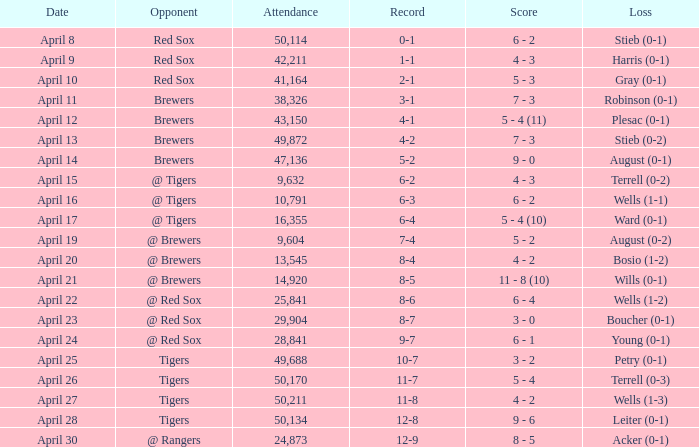Which rival has a decrease in wells numbering between 1 and 3? Tigers. 